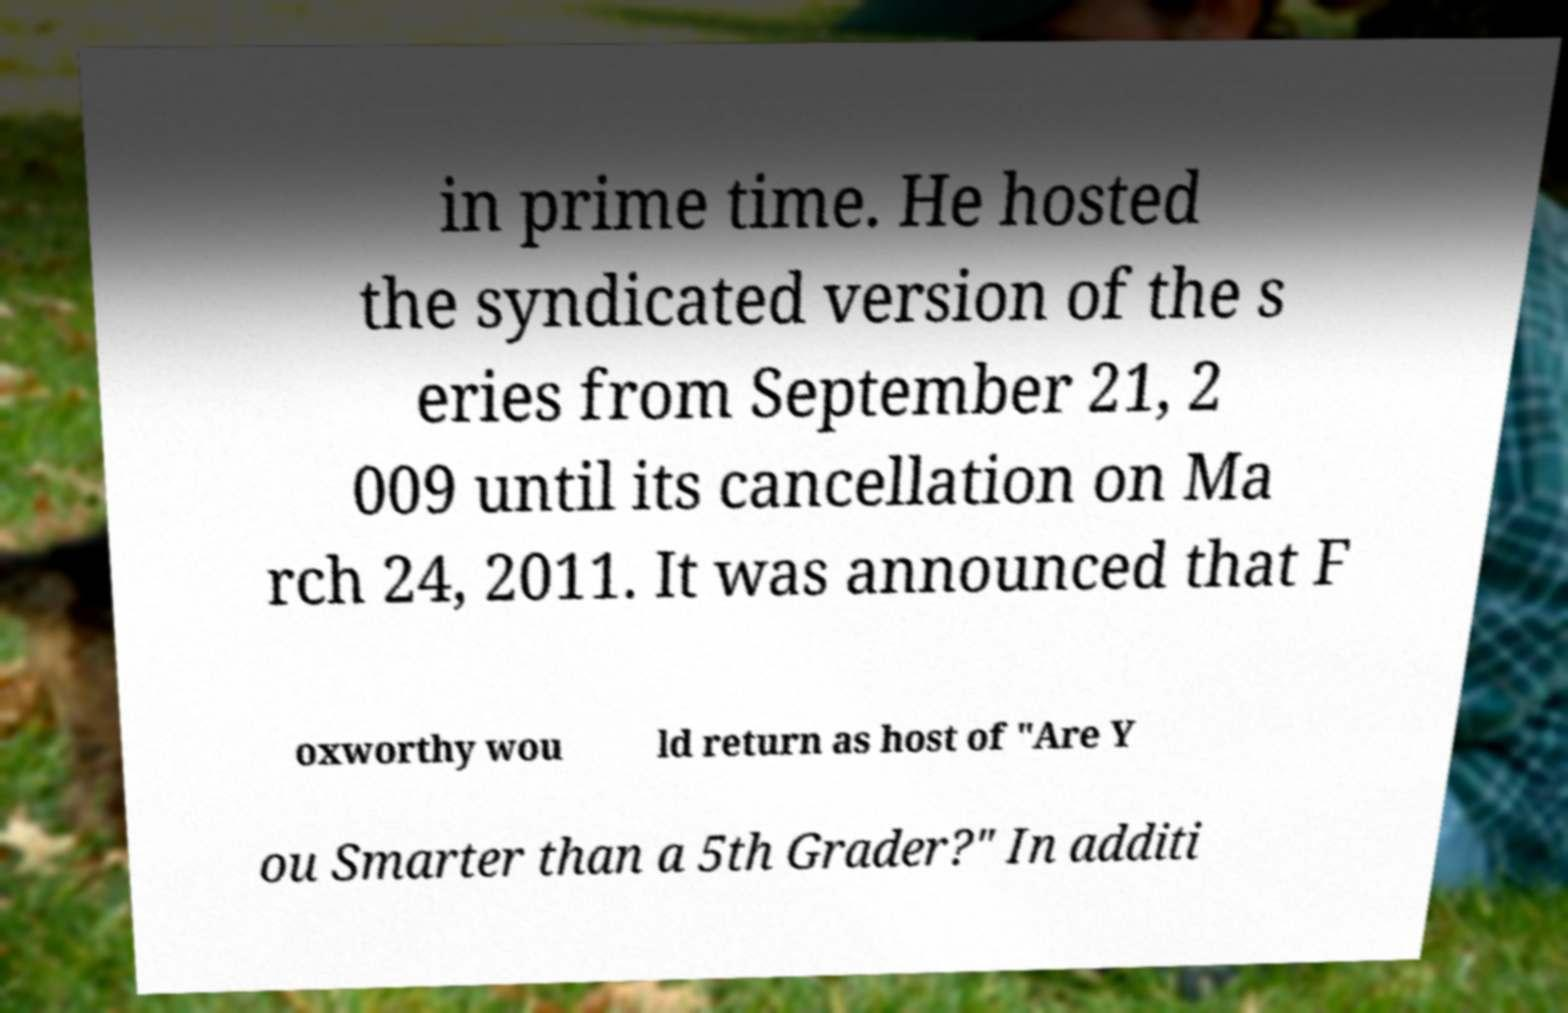Can you read and provide the text displayed in the image?This photo seems to have some interesting text. Can you extract and type it out for me? in prime time. He hosted the syndicated version of the s eries from September 21, 2 009 until its cancellation on Ma rch 24, 2011. It was announced that F oxworthy wou ld return as host of "Are Y ou Smarter than a 5th Grader?" In additi 